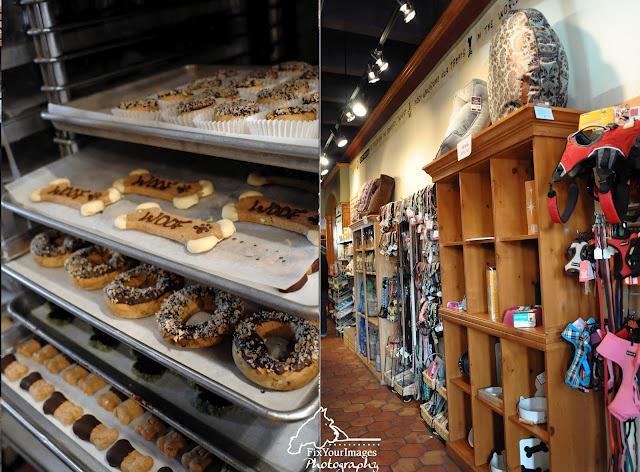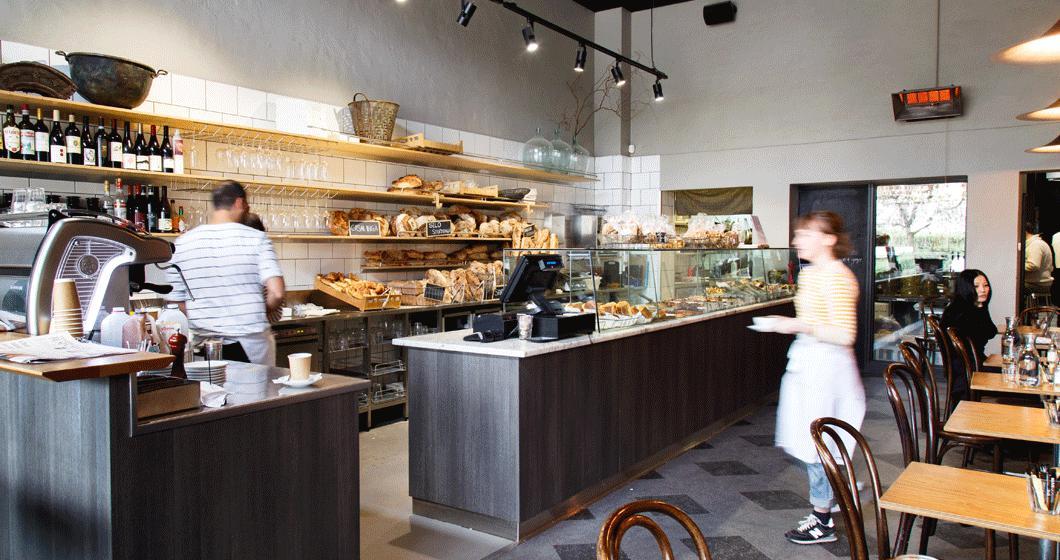The first image is the image on the left, the second image is the image on the right. For the images displayed, is the sentence "One person is standing alone in front of a wooden counter and at least one person is somewhere behind the counter in one image." factually correct? Answer yes or no. Yes. 